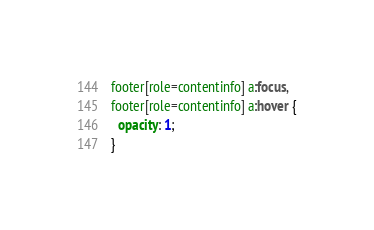<code> <loc_0><loc_0><loc_500><loc_500><_CSS_>footer[role=contentinfo] a:focus,
footer[role=contentinfo] a:hover {
  opacity: 1;
}</code> 